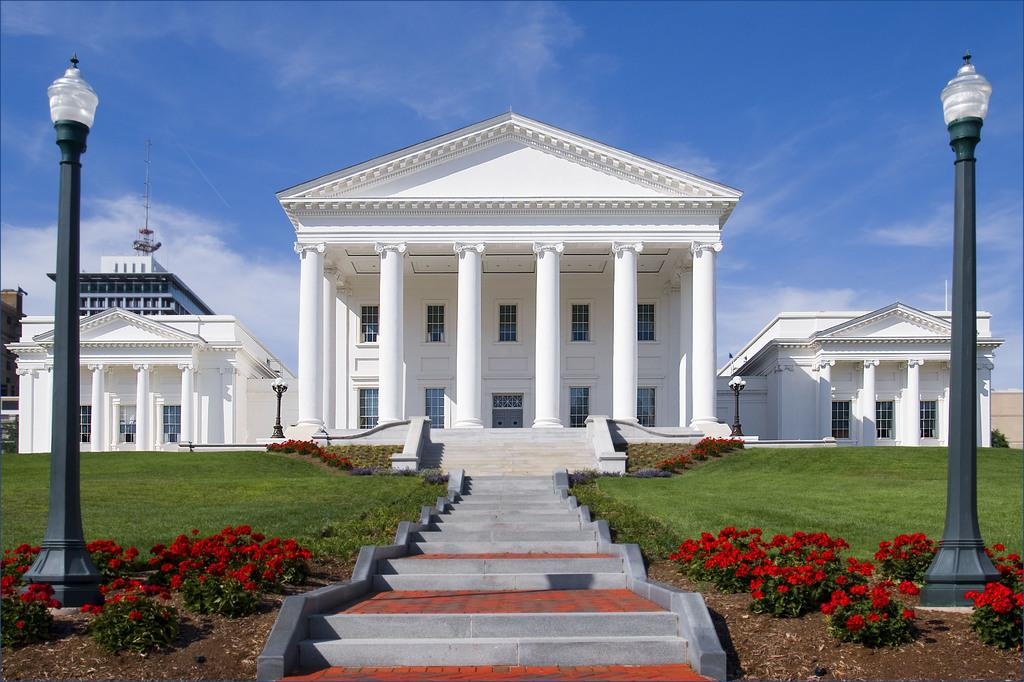What type of plants can be seen in the image? There are plants with flowers in the image. What type of vegetation is present on the ground? There is grass in the image. What structures can be seen in the image? There are poles, lights, buildings, and a staircase in the image. What part of the natural environment is visible in the image? The sky is visible in the image. What type of oil can be seen dripping from the lights in the image? There is no oil present in the image; the lights are not dripping any substance. How many girls are visible in the image? There are no girls present in the image. 